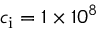Convert formula to latex. <formula><loc_0><loc_0><loc_500><loc_500>c _ { i } = 1 \times 1 0 ^ { 8 }</formula> 